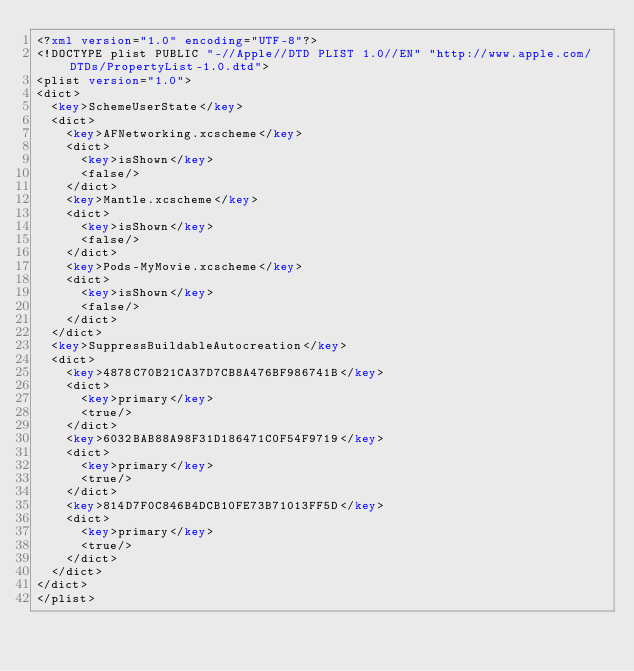<code> <loc_0><loc_0><loc_500><loc_500><_XML_><?xml version="1.0" encoding="UTF-8"?>
<!DOCTYPE plist PUBLIC "-//Apple//DTD PLIST 1.0//EN" "http://www.apple.com/DTDs/PropertyList-1.0.dtd">
<plist version="1.0">
<dict>
	<key>SchemeUserState</key>
	<dict>
		<key>AFNetworking.xcscheme</key>
		<dict>
			<key>isShown</key>
			<false/>
		</dict>
		<key>Mantle.xcscheme</key>
		<dict>
			<key>isShown</key>
			<false/>
		</dict>
		<key>Pods-MyMovie.xcscheme</key>
		<dict>
			<key>isShown</key>
			<false/>
		</dict>
	</dict>
	<key>SuppressBuildableAutocreation</key>
	<dict>
		<key>4878C70B21CA37D7CB8A476BF986741B</key>
		<dict>
			<key>primary</key>
			<true/>
		</dict>
		<key>6032BAB88A98F31D186471C0F54F9719</key>
		<dict>
			<key>primary</key>
			<true/>
		</dict>
		<key>814D7F0C846B4DCB10FE73B71013FF5D</key>
		<dict>
			<key>primary</key>
			<true/>
		</dict>
	</dict>
</dict>
</plist>
</code> 